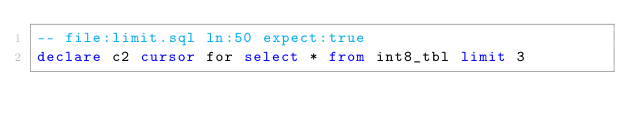<code> <loc_0><loc_0><loc_500><loc_500><_SQL_>-- file:limit.sql ln:50 expect:true
declare c2 cursor for select * from int8_tbl limit 3
</code> 